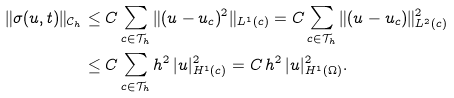<formula> <loc_0><loc_0><loc_500><loc_500>\| \sigma ( u , t ) \| _ { \mathcal { C } _ { h } } & \leq C \sum _ { c \in \mathcal { T } _ { h } } \| ( u - u _ { c } ) ^ { 2 } \| _ { L ^ { 1 } ( c ) } = C \sum _ { c \in \mathcal { T } _ { h } } \| ( u - u _ { c } ) \| ^ { 2 } _ { L ^ { 2 } ( c ) } \\ & \leq C \sum _ { c \in \mathcal { T } _ { h } } h ^ { 2 } \, | u | ^ { 2 } _ { H ^ { 1 } ( c ) } = C \, h ^ { 2 } \, | u | ^ { 2 } _ { H ^ { 1 } ( \Omega ) } .</formula> 